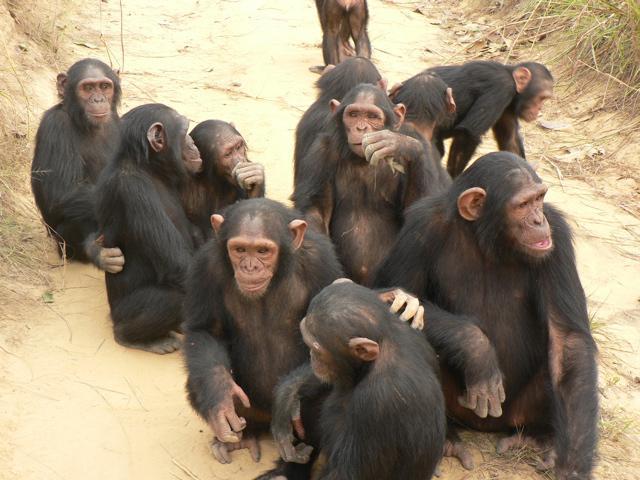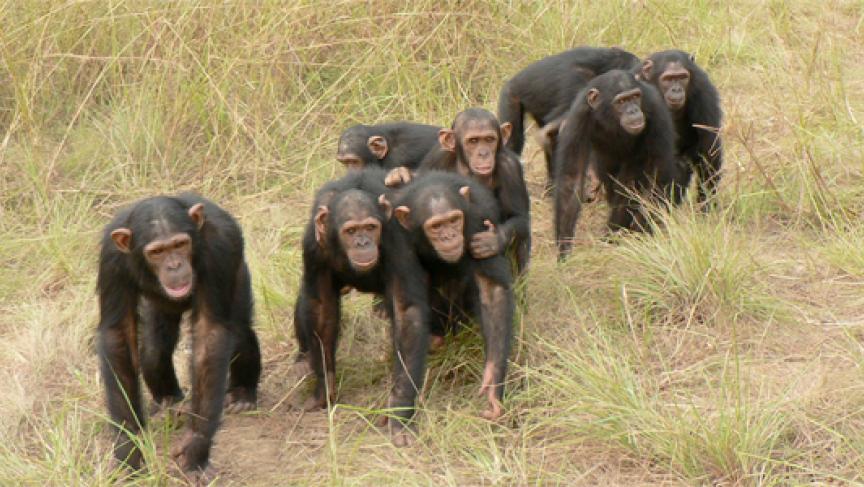The first image is the image on the left, the second image is the image on the right. For the images displayed, is the sentence "Left image contains no more than four chimps, including a close trio." factually correct? Answer yes or no. No. 